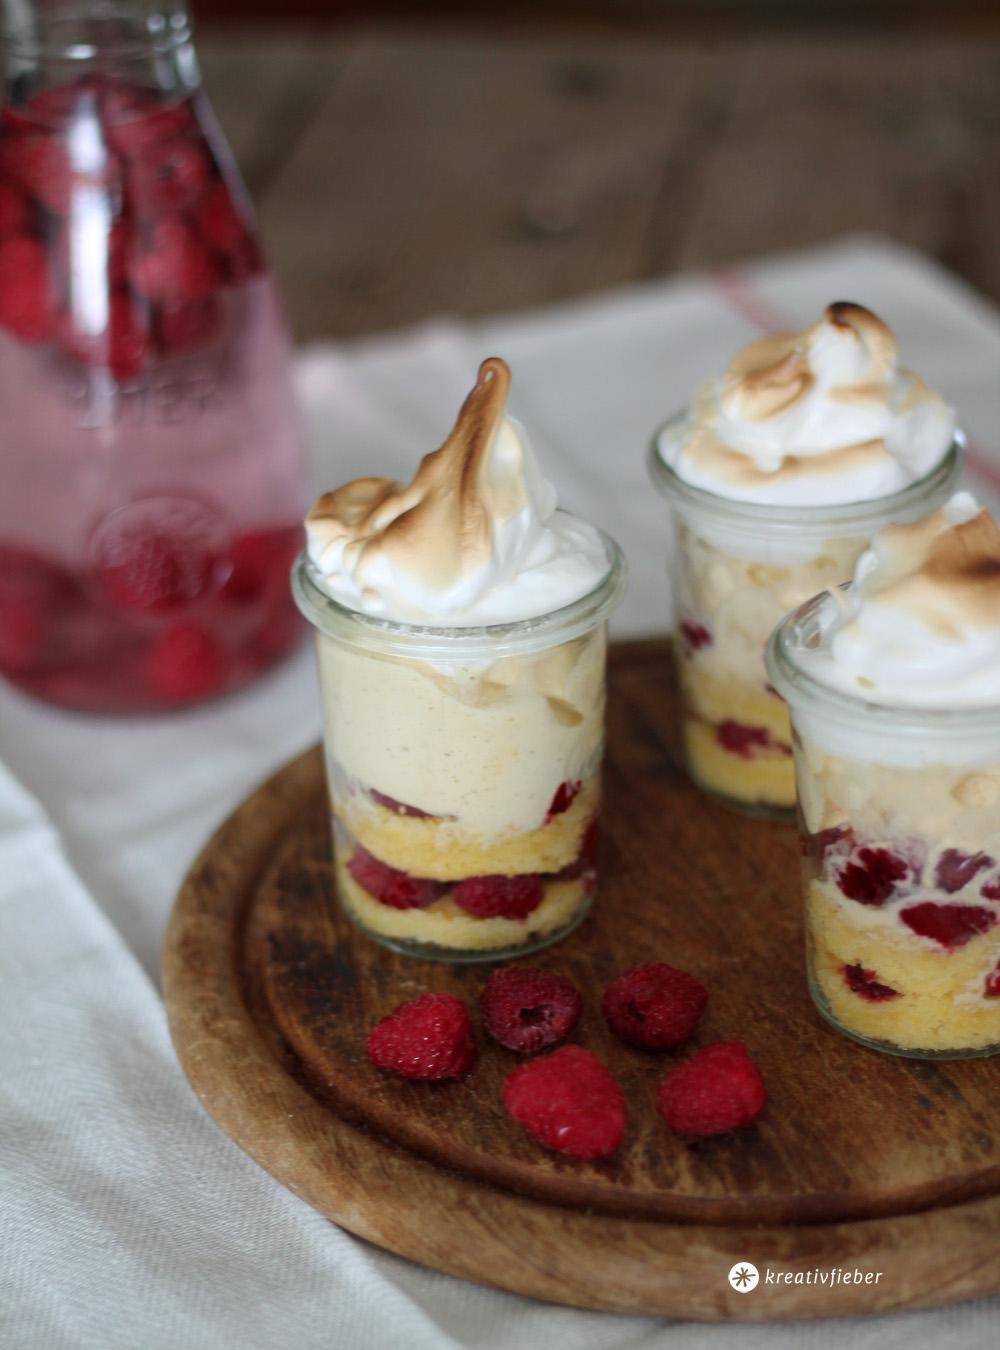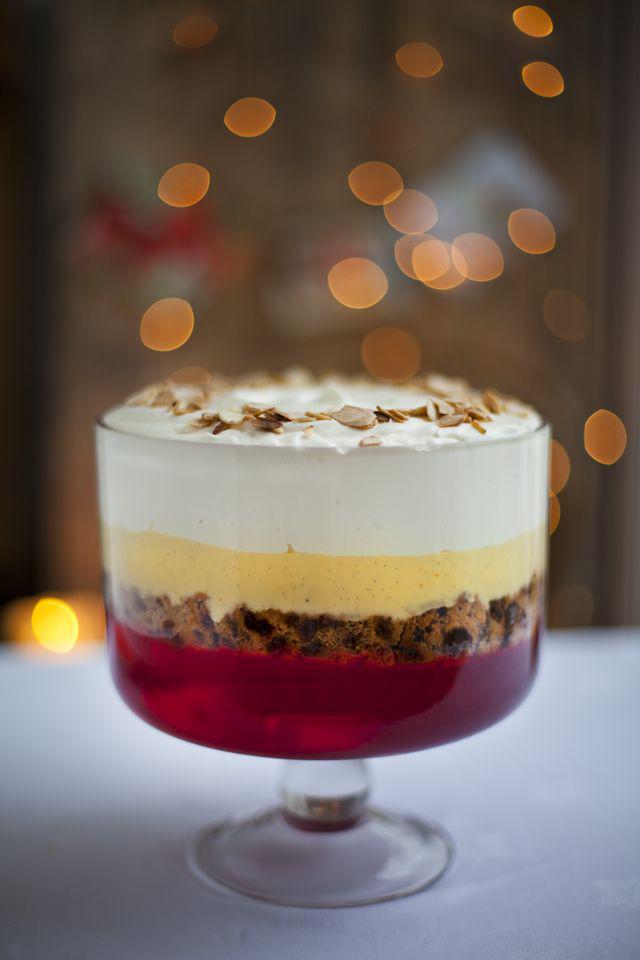The first image is the image on the left, the second image is the image on the right. Assess this claim about the two images: "Two large fruit and cream desserts are ready to serve in clear bowls and are garnished with red fruit.". Correct or not? Answer yes or no. No. The first image is the image on the left, the second image is the image on the right. Assess this claim about the two images: "The desserts in the image on the left are being served in three glasses.". Correct or not? Answer yes or no. Yes. 